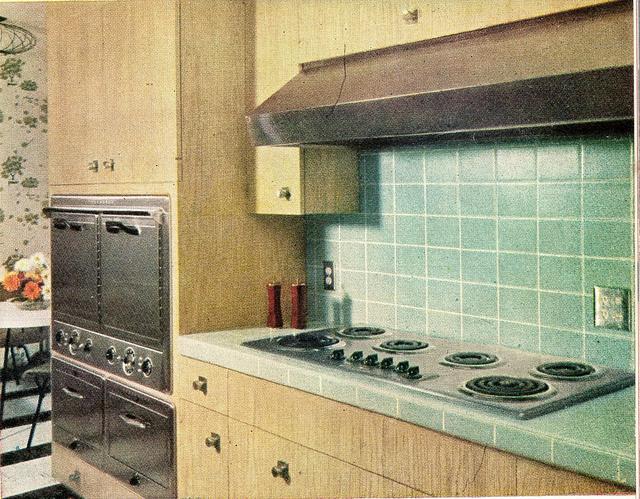Are there any flowers in this picture?
Short answer required. Yes. What pattern is on the floor?
Give a very brief answer. Stripes. How many burners are on this stove-top?
Concise answer only. 6. Is there an electrical outlet anywhere?
Be succinct. Yes. 